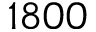Convert formula to latex. <formula><loc_0><loc_0><loc_500><loc_500>1 8 0 0</formula> 